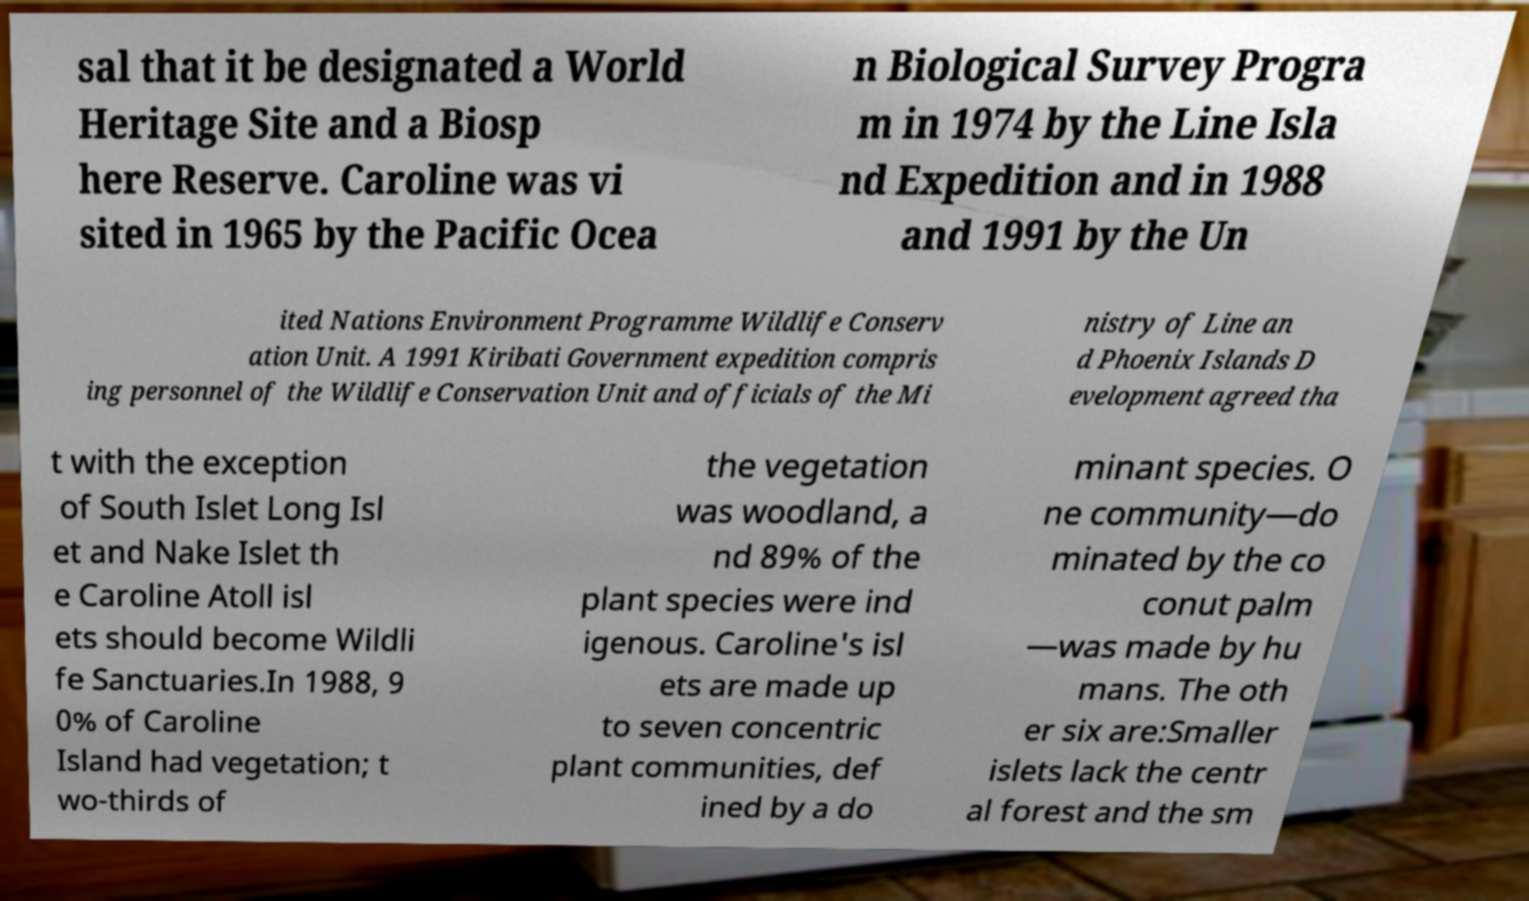Please read and relay the text visible in this image. What does it say? sal that it be designated a World Heritage Site and a Biosp here Reserve. Caroline was vi sited in 1965 by the Pacific Ocea n Biological Survey Progra m in 1974 by the Line Isla nd Expedition and in 1988 and 1991 by the Un ited Nations Environment Programme Wildlife Conserv ation Unit. A 1991 Kiribati Government expedition compris ing personnel of the Wildlife Conservation Unit and officials of the Mi nistry of Line an d Phoenix Islands D evelopment agreed tha t with the exception of South Islet Long Isl et and Nake Islet th e Caroline Atoll isl ets should become Wildli fe Sanctuaries.In 1988, 9 0% of Caroline Island had vegetation; t wo-thirds of the vegetation was woodland, a nd 89% of the plant species were ind igenous. Caroline's isl ets are made up to seven concentric plant communities, def ined by a do minant species. O ne community—do minated by the co conut palm —was made by hu mans. The oth er six are:Smaller islets lack the centr al forest and the sm 